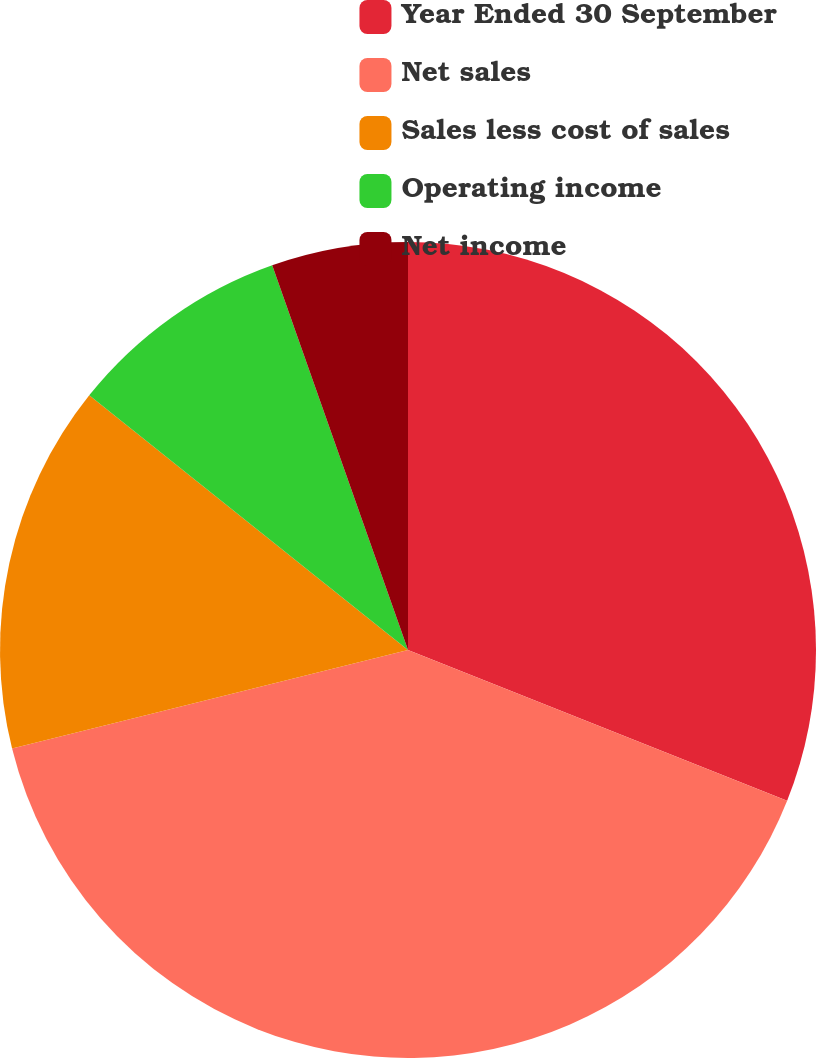Convert chart. <chart><loc_0><loc_0><loc_500><loc_500><pie_chart><fcel>Year Ended 30 September<fcel>Net sales<fcel>Sales less cost of sales<fcel>Operating income<fcel>Net income<nl><fcel>31.02%<fcel>40.09%<fcel>14.61%<fcel>8.87%<fcel>5.4%<nl></chart> 